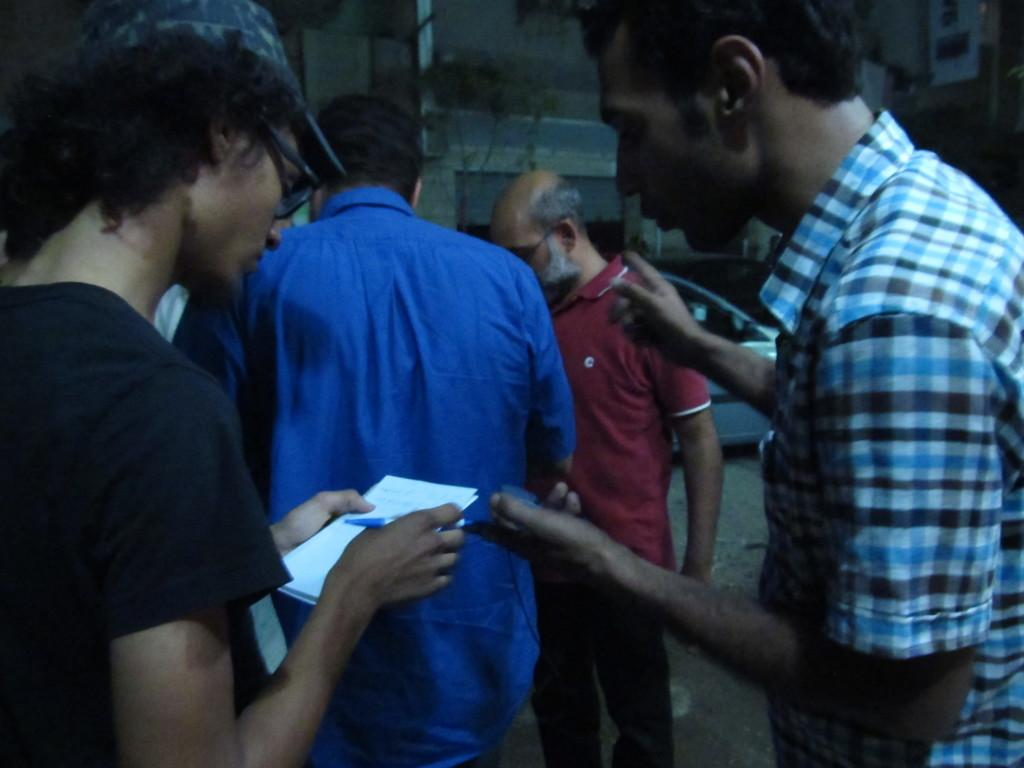What is happening in the foreground of the image? There are people standing in the foreground of the image. What can be seen in the background of the image? There is a car and buildings in the background of the image. What type of bone is visible in the image? There is no bone present in the image. Who is the aunt in the image? There is no mention of an aunt in the image. 